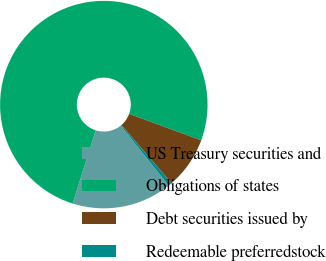Convert chart to OTSL. <chart><loc_0><loc_0><loc_500><loc_500><pie_chart><fcel>US Treasury securities and<fcel>Obligations of states<fcel>Debt securities issued by<fcel>Redeemable preferredstock<nl><fcel>15.6%<fcel>75.74%<fcel>8.09%<fcel>0.57%<nl></chart> 